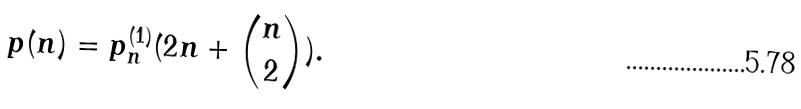Convert formula to latex. <formula><loc_0><loc_0><loc_500><loc_500>p ( n ) = p _ { n } ^ { ( 1 ) } ( 2 n + { n \choose 2 } ) .</formula> 